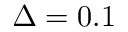<formula> <loc_0><loc_0><loc_500><loc_500>\Delta = 0 . 1</formula> 